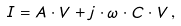<formula> <loc_0><loc_0><loc_500><loc_500>I = A \cdot V + j \cdot \omega \cdot C \cdot V \, ,</formula> 